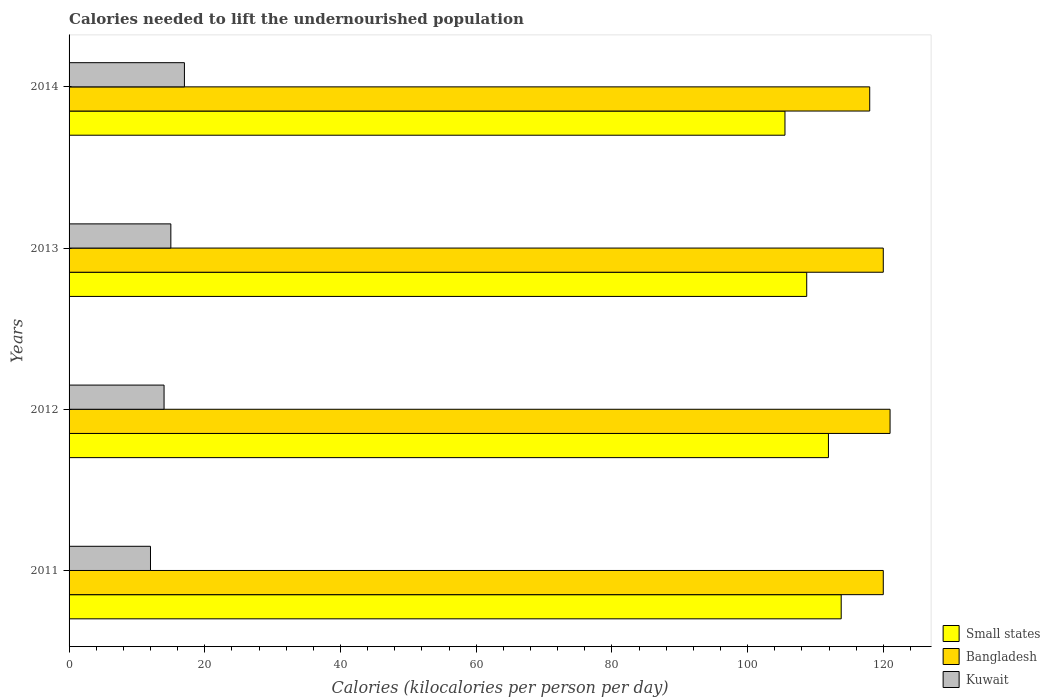Are the number of bars per tick equal to the number of legend labels?
Your answer should be compact. Yes. How many bars are there on the 4th tick from the bottom?
Offer a very short reply. 3. What is the total calories needed to lift the undernourished population in Bangladesh in 2014?
Your answer should be compact. 118. Across all years, what is the maximum total calories needed to lift the undernourished population in Kuwait?
Offer a terse response. 17. Across all years, what is the minimum total calories needed to lift the undernourished population in Kuwait?
Provide a short and direct response. 12. In which year was the total calories needed to lift the undernourished population in Kuwait minimum?
Your answer should be compact. 2011. What is the total total calories needed to lift the undernourished population in Bangladesh in the graph?
Provide a succinct answer. 479. What is the difference between the total calories needed to lift the undernourished population in Bangladesh in 2011 and that in 2012?
Offer a terse response. -1. What is the difference between the total calories needed to lift the undernourished population in Bangladesh in 2011 and the total calories needed to lift the undernourished population in Small states in 2012?
Make the answer very short. 8.08. What is the average total calories needed to lift the undernourished population in Bangladesh per year?
Your answer should be very brief. 119.75. In the year 2014, what is the difference between the total calories needed to lift the undernourished population in Small states and total calories needed to lift the undernourished population in Bangladesh?
Ensure brevity in your answer.  -12.49. In how many years, is the total calories needed to lift the undernourished population in Small states greater than 104 kilocalories?
Provide a short and direct response. 4. What is the ratio of the total calories needed to lift the undernourished population in Small states in 2011 to that in 2012?
Keep it short and to the point. 1.02. Is the difference between the total calories needed to lift the undernourished population in Small states in 2011 and 2012 greater than the difference between the total calories needed to lift the undernourished population in Bangladesh in 2011 and 2012?
Provide a short and direct response. Yes. What is the difference between the highest and the second highest total calories needed to lift the undernourished population in Small states?
Ensure brevity in your answer.  1.88. What is the difference between the highest and the lowest total calories needed to lift the undernourished population in Kuwait?
Your answer should be very brief. 5. Is the sum of the total calories needed to lift the undernourished population in Small states in 2011 and 2014 greater than the maximum total calories needed to lift the undernourished population in Bangladesh across all years?
Keep it short and to the point. Yes. What does the 1st bar from the top in 2014 represents?
Give a very brief answer. Kuwait. What does the 1st bar from the bottom in 2013 represents?
Your response must be concise. Small states. Is it the case that in every year, the sum of the total calories needed to lift the undernourished population in Small states and total calories needed to lift the undernourished population in Bangladesh is greater than the total calories needed to lift the undernourished population in Kuwait?
Offer a very short reply. Yes. How many bars are there?
Ensure brevity in your answer.  12. How many years are there in the graph?
Provide a short and direct response. 4. What is the difference between two consecutive major ticks on the X-axis?
Give a very brief answer. 20. Are the values on the major ticks of X-axis written in scientific E-notation?
Provide a short and direct response. No. Does the graph contain any zero values?
Offer a terse response. No. Does the graph contain grids?
Provide a short and direct response. No. Where does the legend appear in the graph?
Make the answer very short. Bottom right. How many legend labels are there?
Your answer should be compact. 3. How are the legend labels stacked?
Offer a terse response. Vertical. What is the title of the graph?
Give a very brief answer. Calories needed to lift the undernourished population. Does "Lao PDR" appear as one of the legend labels in the graph?
Offer a terse response. No. What is the label or title of the X-axis?
Offer a terse response. Calories (kilocalories per person per day). What is the Calories (kilocalories per person per day) in Small states in 2011?
Your answer should be compact. 113.8. What is the Calories (kilocalories per person per day) of Bangladesh in 2011?
Provide a short and direct response. 120. What is the Calories (kilocalories per person per day) in Kuwait in 2011?
Offer a terse response. 12. What is the Calories (kilocalories per person per day) of Small states in 2012?
Keep it short and to the point. 111.92. What is the Calories (kilocalories per person per day) in Bangladesh in 2012?
Ensure brevity in your answer.  121. What is the Calories (kilocalories per person per day) in Kuwait in 2012?
Provide a succinct answer. 14. What is the Calories (kilocalories per person per day) in Small states in 2013?
Offer a very short reply. 108.72. What is the Calories (kilocalories per person per day) in Bangladesh in 2013?
Your answer should be very brief. 120. What is the Calories (kilocalories per person per day) in Small states in 2014?
Ensure brevity in your answer.  105.51. What is the Calories (kilocalories per person per day) of Bangladesh in 2014?
Give a very brief answer. 118. What is the Calories (kilocalories per person per day) of Kuwait in 2014?
Offer a terse response. 17. Across all years, what is the maximum Calories (kilocalories per person per day) in Small states?
Your answer should be very brief. 113.8. Across all years, what is the maximum Calories (kilocalories per person per day) in Bangladesh?
Your response must be concise. 121. Across all years, what is the minimum Calories (kilocalories per person per day) of Small states?
Keep it short and to the point. 105.51. Across all years, what is the minimum Calories (kilocalories per person per day) in Bangladesh?
Provide a short and direct response. 118. Across all years, what is the minimum Calories (kilocalories per person per day) in Kuwait?
Your answer should be very brief. 12. What is the total Calories (kilocalories per person per day) in Small states in the graph?
Offer a terse response. 439.94. What is the total Calories (kilocalories per person per day) of Bangladesh in the graph?
Offer a terse response. 479. What is the total Calories (kilocalories per person per day) in Kuwait in the graph?
Your answer should be very brief. 58. What is the difference between the Calories (kilocalories per person per day) of Small states in 2011 and that in 2012?
Provide a short and direct response. 1.88. What is the difference between the Calories (kilocalories per person per day) in Kuwait in 2011 and that in 2012?
Keep it short and to the point. -2. What is the difference between the Calories (kilocalories per person per day) of Small states in 2011 and that in 2013?
Ensure brevity in your answer.  5.08. What is the difference between the Calories (kilocalories per person per day) of Small states in 2011 and that in 2014?
Provide a succinct answer. 8.29. What is the difference between the Calories (kilocalories per person per day) of Kuwait in 2011 and that in 2014?
Offer a terse response. -5. What is the difference between the Calories (kilocalories per person per day) of Small states in 2012 and that in 2013?
Provide a succinct answer. 3.2. What is the difference between the Calories (kilocalories per person per day) in Small states in 2012 and that in 2014?
Offer a terse response. 6.41. What is the difference between the Calories (kilocalories per person per day) of Bangladesh in 2012 and that in 2014?
Your response must be concise. 3. What is the difference between the Calories (kilocalories per person per day) in Small states in 2013 and that in 2014?
Give a very brief answer. 3.21. What is the difference between the Calories (kilocalories per person per day) in Bangladesh in 2013 and that in 2014?
Your answer should be very brief. 2. What is the difference between the Calories (kilocalories per person per day) of Small states in 2011 and the Calories (kilocalories per person per day) of Bangladesh in 2012?
Make the answer very short. -7.2. What is the difference between the Calories (kilocalories per person per day) of Small states in 2011 and the Calories (kilocalories per person per day) of Kuwait in 2012?
Give a very brief answer. 99.8. What is the difference between the Calories (kilocalories per person per day) of Bangladesh in 2011 and the Calories (kilocalories per person per day) of Kuwait in 2012?
Offer a terse response. 106. What is the difference between the Calories (kilocalories per person per day) of Small states in 2011 and the Calories (kilocalories per person per day) of Bangladesh in 2013?
Provide a short and direct response. -6.2. What is the difference between the Calories (kilocalories per person per day) of Small states in 2011 and the Calories (kilocalories per person per day) of Kuwait in 2013?
Make the answer very short. 98.8. What is the difference between the Calories (kilocalories per person per day) of Bangladesh in 2011 and the Calories (kilocalories per person per day) of Kuwait in 2013?
Your answer should be very brief. 105. What is the difference between the Calories (kilocalories per person per day) of Small states in 2011 and the Calories (kilocalories per person per day) of Bangladesh in 2014?
Your answer should be compact. -4.2. What is the difference between the Calories (kilocalories per person per day) in Small states in 2011 and the Calories (kilocalories per person per day) in Kuwait in 2014?
Provide a short and direct response. 96.8. What is the difference between the Calories (kilocalories per person per day) in Bangladesh in 2011 and the Calories (kilocalories per person per day) in Kuwait in 2014?
Offer a terse response. 103. What is the difference between the Calories (kilocalories per person per day) of Small states in 2012 and the Calories (kilocalories per person per day) of Bangladesh in 2013?
Give a very brief answer. -8.08. What is the difference between the Calories (kilocalories per person per day) in Small states in 2012 and the Calories (kilocalories per person per day) in Kuwait in 2013?
Offer a terse response. 96.92. What is the difference between the Calories (kilocalories per person per day) of Bangladesh in 2012 and the Calories (kilocalories per person per day) of Kuwait in 2013?
Give a very brief answer. 106. What is the difference between the Calories (kilocalories per person per day) of Small states in 2012 and the Calories (kilocalories per person per day) of Bangladesh in 2014?
Your response must be concise. -6.08. What is the difference between the Calories (kilocalories per person per day) of Small states in 2012 and the Calories (kilocalories per person per day) of Kuwait in 2014?
Your response must be concise. 94.92. What is the difference between the Calories (kilocalories per person per day) in Bangladesh in 2012 and the Calories (kilocalories per person per day) in Kuwait in 2014?
Your answer should be compact. 104. What is the difference between the Calories (kilocalories per person per day) in Small states in 2013 and the Calories (kilocalories per person per day) in Bangladesh in 2014?
Offer a very short reply. -9.28. What is the difference between the Calories (kilocalories per person per day) of Small states in 2013 and the Calories (kilocalories per person per day) of Kuwait in 2014?
Make the answer very short. 91.72. What is the difference between the Calories (kilocalories per person per day) of Bangladesh in 2013 and the Calories (kilocalories per person per day) of Kuwait in 2014?
Your answer should be compact. 103. What is the average Calories (kilocalories per person per day) of Small states per year?
Provide a short and direct response. 109.99. What is the average Calories (kilocalories per person per day) in Bangladesh per year?
Your answer should be compact. 119.75. In the year 2011, what is the difference between the Calories (kilocalories per person per day) of Small states and Calories (kilocalories per person per day) of Bangladesh?
Your answer should be very brief. -6.2. In the year 2011, what is the difference between the Calories (kilocalories per person per day) in Small states and Calories (kilocalories per person per day) in Kuwait?
Ensure brevity in your answer.  101.8. In the year 2011, what is the difference between the Calories (kilocalories per person per day) of Bangladesh and Calories (kilocalories per person per day) of Kuwait?
Keep it short and to the point. 108. In the year 2012, what is the difference between the Calories (kilocalories per person per day) of Small states and Calories (kilocalories per person per day) of Bangladesh?
Your answer should be compact. -9.08. In the year 2012, what is the difference between the Calories (kilocalories per person per day) of Small states and Calories (kilocalories per person per day) of Kuwait?
Offer a terse response. 97.92. In the year 2012, what is the difference between the Calories (kilocalories per person per day) in Bangladesh and Calories (kilocalories per person per day) in Kuwait?
Provide a short and direct response. 107. In the year 2013, what is the difference between the Calories (kilocalories per person per day) of Small states and Calories (kilocalories per person per day) of Bangladesh?
Keep it short and to the point. -11.28. In the year 2013, what is the difference between the Calories (kilocalories per person per day) in Small states and Calories (kilocalories per person per day) in Kuwait?
Offer a terse response. 93.72. In the year 2013, what is the difference between the Calories (kilocalories per person per day) of Bangladesh and Calories (kilocalories per person per day) of Kuwait?
Give a very brief answer. 105. In the year 2014, what is the difference between the Calories (kilocalories per person per day) of Small states and Calories (kilocalories per person per day) of Bangladesh?
Keep it short and to the point. -12.49. In the year 2014, what is the difference between the Calories (kilocalories per person per day) in Small states and Calories (kilocalories per person per day) in Kuwait?
Give a very brief answer. 88.51. In the year 2014, what is the difference between the Calories (kilocalories per person per day) of Bangladesh and Calories (kilocalories per person per day) of Kuwait?
Make the answer very short. 101. What is the ratio of the Calories (kilocalories per person per day) of Small states in 2011 to that in 2012?
Your response must be concise. 1.02. What is the ratio of the Calories (kilocalories per person per day) of Bangladesh in 2011 to that in 2012?
Give a very brief answer. 0.99. What is the ratio of the Calories (kilocalories per person per day) in Kuwait in 2011 to that in 2012?
Your answer should be very brief. 0.86. What is the ratio of the Calories (kilocalories per person per day) of Small states in 2011 to that in 2013?
Your response must be concise. 1.05. What is the ratio of the Calories (kilocalories per person per day) in Kuwait in 2011 to that in 2013?
Provide a succinct answer. 0.8. What is the ratio of the Calories (kilocalories per person per day) in Small states in 2011 to that in 2014?
Offer a terse response. 1.08. What is the ratio of the Calories (kilocalories per person per day) in Bangladesh in 2011 to that in 2014?
Your answer should be very brief. 1.02. What is the ratio of the Calories (kilocalories per person per day) of Kuwait in 2011 to that in 2014?
Your answer should be compact. 0.71. What is the ratio of the Calories (kilocalories per person per day) in Small states in 2012 to that in 2013?
Offer a terse response. 1.03. What is the ratio of the Calories (kilocalories per person per day) of Bangladesh in 2012 to that in 2013?
Offer a very short reply. 1.01. What is the ratio of the Calories (kilocalories per person per day) in Kuwait in 2012 to that in 2013?
Your answer should be compact. 0.93. What is the ratio of the Calories (kilocalories per person per day) in Small states in 2012 to that in 2014?
Make the answer very short. 1.06. What is the ratio of the Calories (kilocalories per person per day) in Bangladesh in 2012 to that in 2014?
Your response must be concise. 1.03. What is the ratio of the Calories (kilocalories per person per day) of Kuwait in 2012 to that in 2014?
Offer a very short reply. 0.82. What is the ratio of the Calories (kilocalories per person per day) in Small states in 2013 to that in 2014?
Offer a very short reply. 1.03. What is the ratio of the Calories (kilocalories per person per day) of Bangladesh in 2013 to that in 2014?
Give a very brief answer. 1.02. What is the ratio of the Calories (kilocalories per person per day) of Kuwait in 2013 to that in 2014?
Your answer should be compact. 0.88. What is the difference between the highest and the second highest Calories (kilocalories per person per day) in Small states?
Your answer should be very brief. 1.88. What is the difference between the highest and the second highest Calories (kilocalories per person per day) of Bangladesh?
Offer a very short reply. 1. What is the difference between the highest and the lowest Calories (kilocalories per person per day) in Small states?
Your response must be concise. 8.29. 